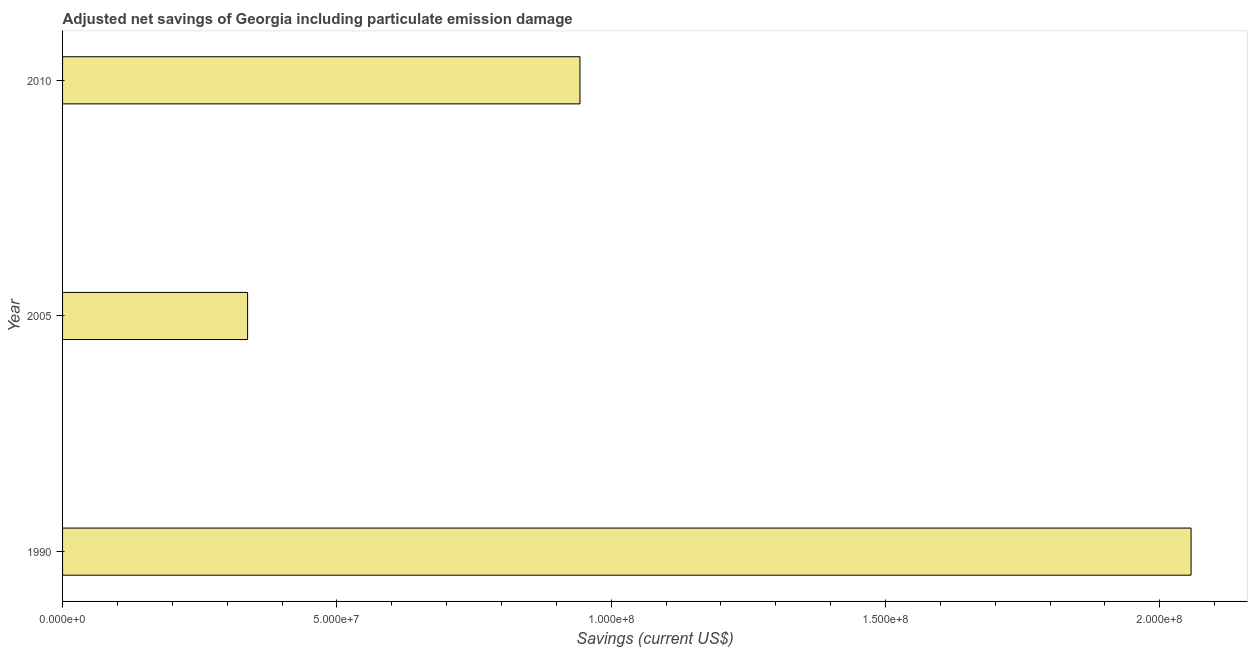Does the graph contain grids?
Provide a short and direct response. No. What is the title of the graph?
Keep it short and to the point. Adjusted net savings of Georgia including particulate emission damage. What is the label or title of the X-axis?
Keep it short and to the point. Savings (current US$). What is the label or title of the Y-axis?
Your answer should be very brief. Year. What is the adjusted net savings in 2010?
Your answer should be compact. 9.43e+07. Across all years, what is the maximum adjusted net savings?
Offer a very short reply. 2.06e+08. Across all years, what is the minimum adjusted net savings?
Your answer should be compact. 3.37e+07. In which year was the adjusted net savings maximum?
Provide a short and direct response. 1990. What is the sum of the adjusted net savings?
Your answer should be compact. 3.34e+08. What is the difference between the adjusted net savings in 1990 and 2005?
Give a very brief answer. 1.72e+08. What is the average adjusted net savings per year?
Offer a very short reply. 1.11e+08. What is the median adjusted net savings?
Offer a very short reply. 9.43e+07. What is the ratio of the adjusted net savings in 2005 to that in 2010?
Your answer should be very brief. 0.36. Is the adjusted net savings in 1990 less than that in 2005?
Provide a succinct answer. No. Is the difference between the adjusted net savings in 1990 and 2005 greater than the difference between any two years?
Your answer should be compact. Yes. What is the difference between the highest and the second highest adjusted net savings?
Your response must be concise. 1.11e+08. What is the difference between the highest and the lowest adjusted net savings?
Give a very brief answer. 1.72e+08. In how many years, is the adjusted net savings greater than the average adjusted net savings taken over all years?
Keep it short and to the point. 1. Are all the bars in the graph horizontal?
Provide a short and direct response. Yes. How many years are there in the graph?
Your answer should be compact. 3. What is the difference between two consecutive major ticks on the X-axis?
Your answer should be very brief. 5.00e+07. Are the values on the major ticks of X-axis written in scientific E-notation?
Provide a short and direct response. Yes. What is the Savings (current US$) of 1990?
Your answer should be very brief. 2.06e+08. What is the Savings (current US$) in 2005?
Provide a short and direct response. 3.37e+07. What is the Savings (current US$) in 2010?
Your answer should be very brief. 9.43e+07. What is the difference between the Savings (current US$) in 1990 and 2005?
Offer a terse response. 1.72e+08. What is the difference between the Savings (current US$) in 1990 and 2010?
Provide a short and direct response. 1.11e+08. What is the difference between the Savings (current US$) in 2005 and 2010?
Your answer should be compact. -6.06e+07. What is the ratio of the Savings (current US$) in 1990 to that in 2005?
Make the answer very short. 6.1. What is the ratio of the Savings (current US$) in 1990 to that in 2010?
Your answer should be very brief. 2.18. What is the ratio of the Savings (current US$) in 2005 to that in 2010?
Your answer should be compact. 0.36. 